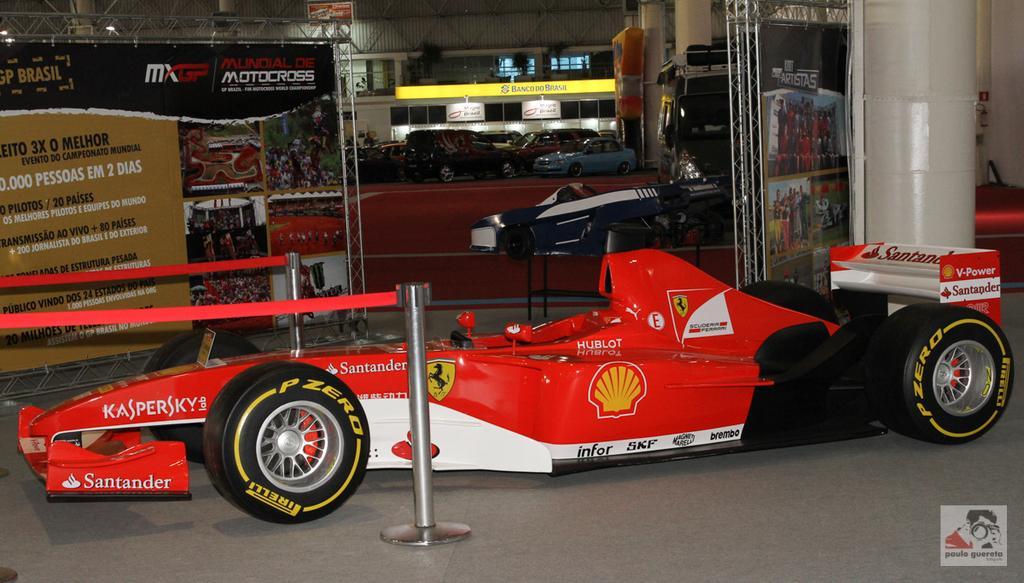Describe this image in one or two sentences. In this image we can see a Santander on the floor. In the background we can see hoardings with text and images. Image also consists of many cars. There is a white pillar and a red carpet on the floor. At the bottom there is logo. 